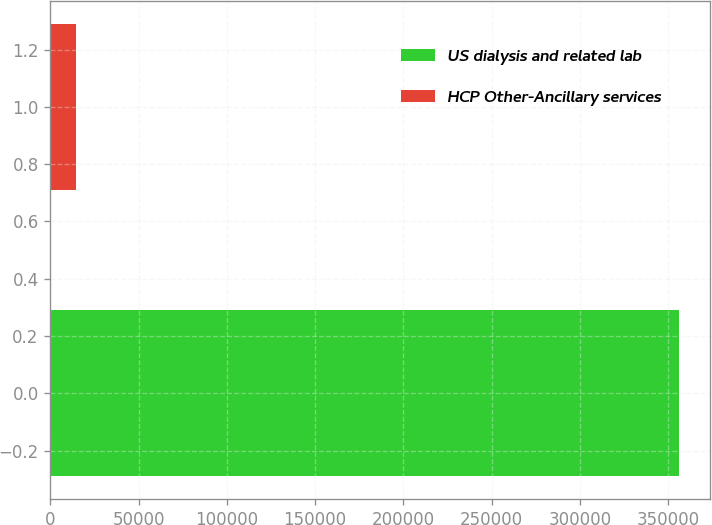<chart> <loc_0><loc_0><loc_500><loc_500><bar_chart><fcel>US dialysis and related lab<fcel>HCP Other-Ancillary services<nl><fcel>355879<fcel>14502<nl></chart> 